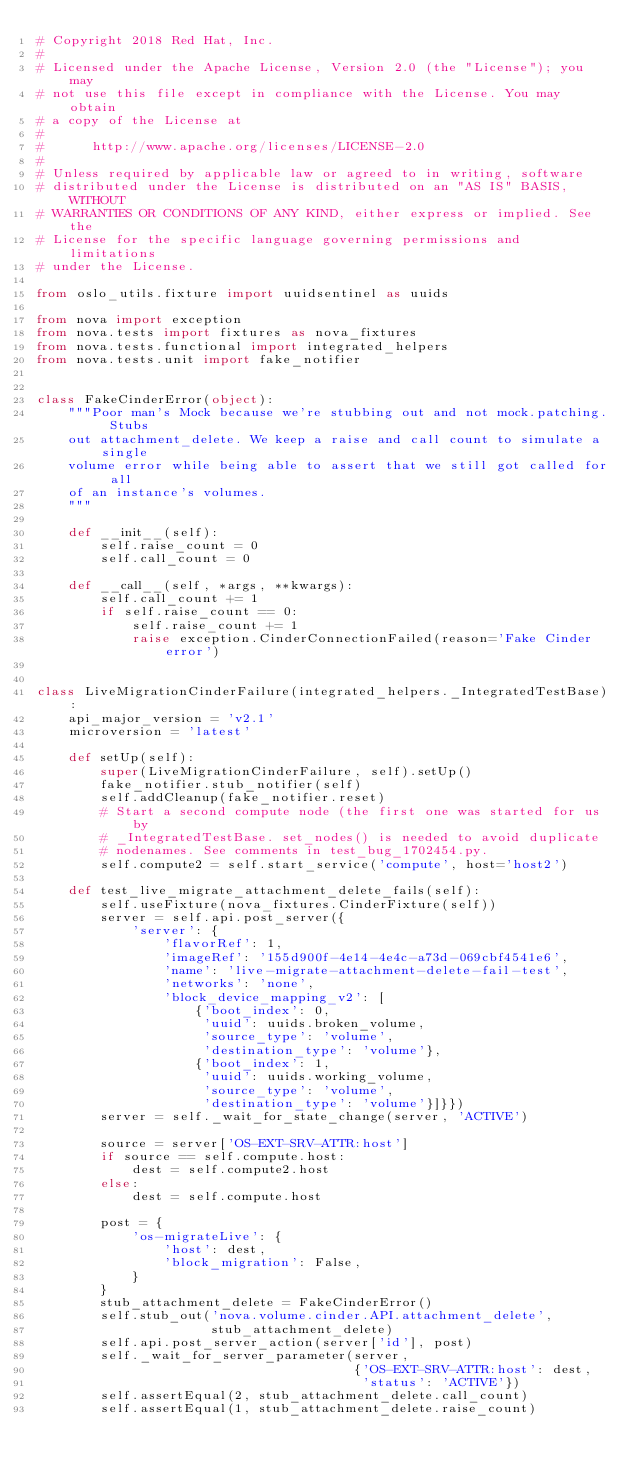Convert code to text. <code><loc_0><loc_0><loc_500><loc_500><_Python_># Copyright 2018 Red Hat, Inc.
#
# Licensed under the Apache License, Version 2.0 (the "License"); you may
# not use this file except in compliance with the License. You may obtain
# a copy of the License at
#
#      http://www.apache.org/licenses/LICENSE-2.0
#
# Unless required by applicable law or agreed to in writing, software
# distributed under the License is distributed on an "AS IS" BASIS, WITHOUT
# WARRANTIES OR CONDITIONS OF ANY KIND, either express or implied. See the
# License for the specific language governing permissions and limitations
# under the License.

from oslo_utils.fixture import uuidsentinel as uuids

from nova import exception
from nova.tests import fixtures as nova_fixtures
from nova.tests.functional import integrated_helpers
from nova.tests.unit import fake_notifier


class FakeCinderError(object):
    """Poor man's Mock because we're stubbing out and not mock.patching. Stubs
    out attachment_delete. We keep a raise and call count to simulate a single
    volume error while being able to assert that we still got called for all
    of an instance's volumes.
    """

    def __init__(self):
        self.raise_count = 0
        self.call_count = 0

    def __call__(self, *args, **kwargs):
        self.call_count += 1
        if self.raise_count == 0:
            self.raise_count += 1
            raise exception.CinderConnectionFailed(reason='Fake Cinder error')


class LiveMigrationCinderFailure(integrated_helpers._IntegratedTestBase):
    api_major_version = 'v2.1'
    microversion = 'latest'

    def setUp(self):
        super(LiveMigrationCinderFailure, self).setUp()
        fake_notifier.stub_notifier(self)
        self.addCleanup(fake_notifier.reset)
        # Start a second compute node (the first one was started for us by
        # _IntegratedTestBase. set_nodes() is needed to avoid duplicate
        # nodenames. See comments in test_bug_1702454.py.
        self.compute2 = self.start_service('compute', host='host2')

    def test_live_migrate_attachment_delete_fails(self):
        self.useFixture(nova_fixtures.CinderFixture(self))
        server = self.api.post_server({
            'server': {
                'flavorRef': 1,
                'imageRef': '155d900f-4e14-4e4c-a73d-069cbf4541e6',
                'name': 'live-migrate-attachment-delete-fail-test',
                'networks': 'none',
                'block_device_mapping_v2': [
                    {'boot_index': 0,
                     'uuid': uuids.broken_volume,
                     'source_type': 'volume',
                     'destination_type': 'volume'},
                    {'boot_index': 1,
                     'uuid': uuids.working_volume,
                     'source_type': 'volume',
                     'destination_type': 'volume'}]}})
        server = self._wait_for_state_change(server, 'ACTIVE')

        source = server['OS-EXT-SRV-ATTR:host']
        if source == self.compute.host:
            dest = self.compute2.host
        else:
            dest = self.compute.host

        post = {
            'os-migrateLive': {
                'host': dest,
                'block_migration': False,
            }
        }
        stub_attachment_delete = FakeCinderError()
        self.stub_out('nova.volume.cinder.API.attachment_delete',
                      stub_attachment_delete)
        self.api.post_server_action(server['id'], post)
        self._wait_for_server_parameter(server,
                                        {'OS-EXT-SRV-ATTR:host': dest,
                                         'status': 'ACTIVE'})
        self.assertEqual(2, stub_attachment_delete.call_count)
        self.assertEqual(1, stub_attachment_delete.raise_count)
</code> 